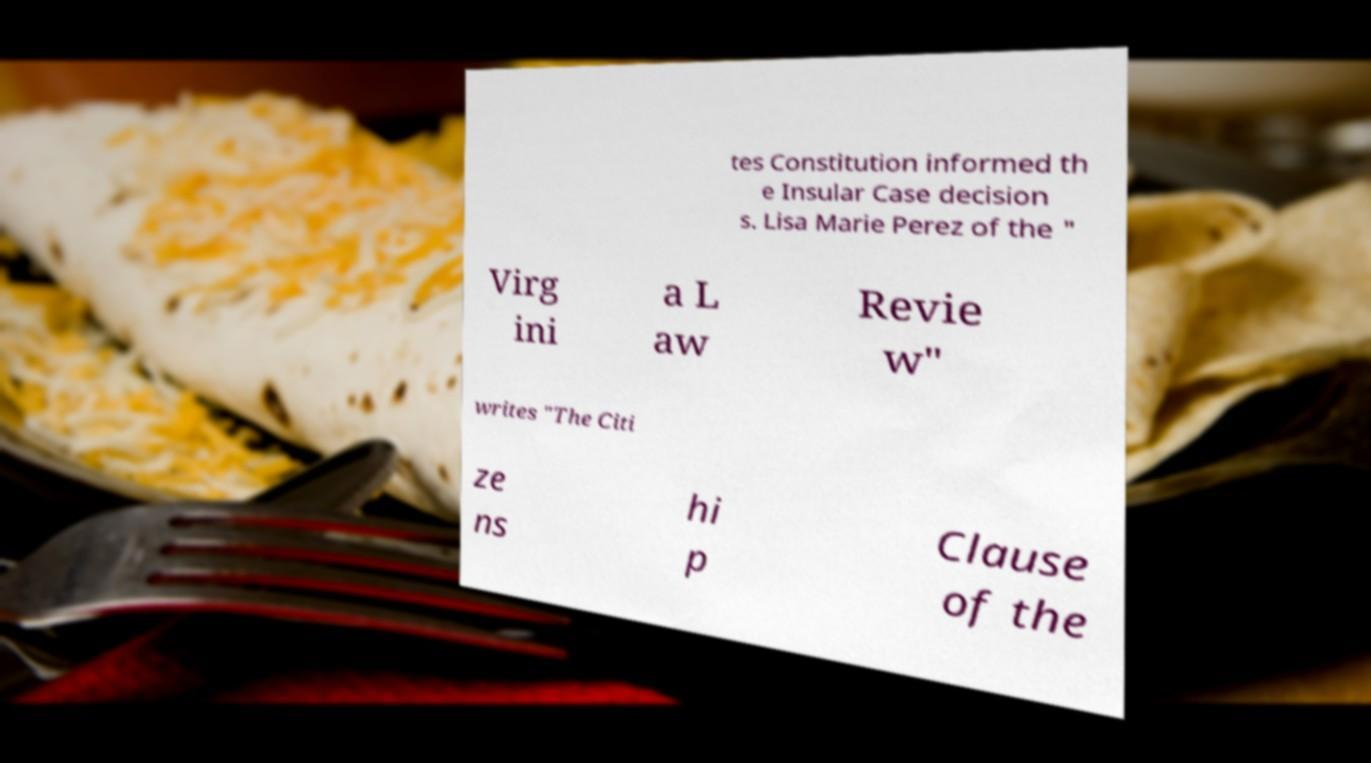Please read and relay the text visible in this image. What does it say? tes Constitution informed th e Insular Case decision s. Lisa Marie Perez of the " Virg ini a L aw Revie w" writes "The Citi ze ns hi p Clause of the 